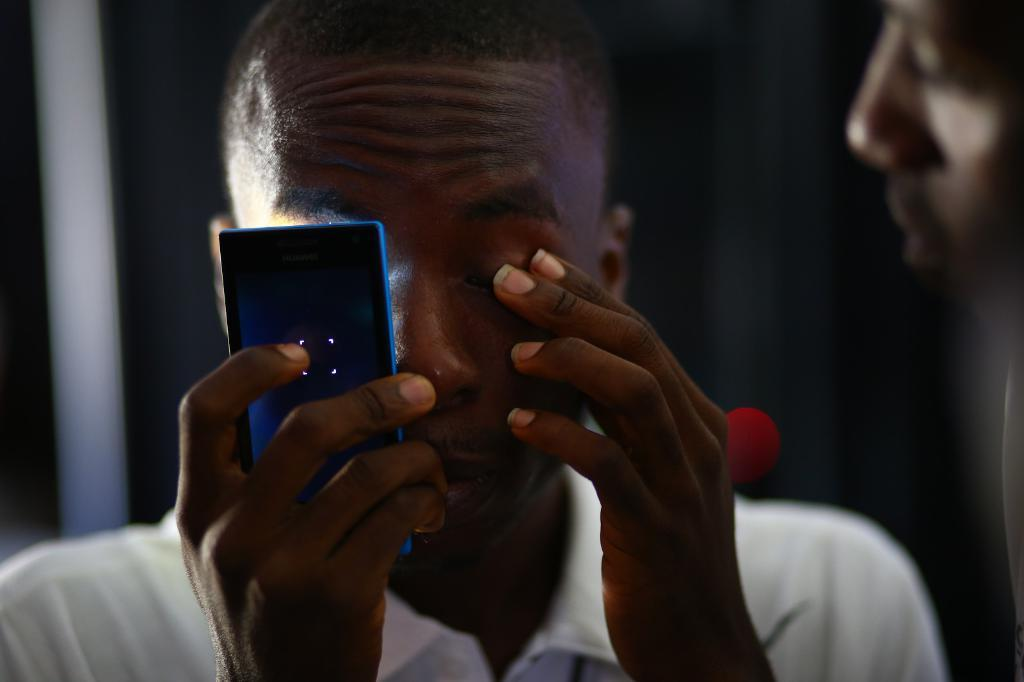What is the main subject of the image? There is a person in the image. What is the person holding in his hand? The person is holding a mobile phone in his hand. What type of tin can be seen hanging from the person's neck in the image? There is no tin present in the image; the person is holding a mobile phone. What sound does the bell make in the image? There is no bell present in the image. 